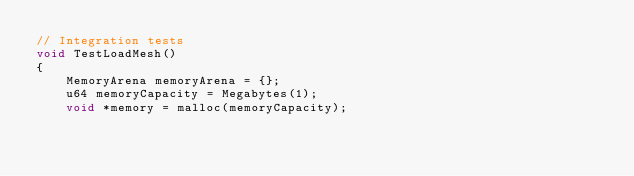<code> <loc_0><loc_0><loc_500><loc_500><_C++_>// Integration tests
void TestLoadMesh()
{
    MemoryArena memoryArena = {};
    u64 memoryCapacity = Megabytes(1);
    void *memory = malloc(memoryCapacity);</code> 